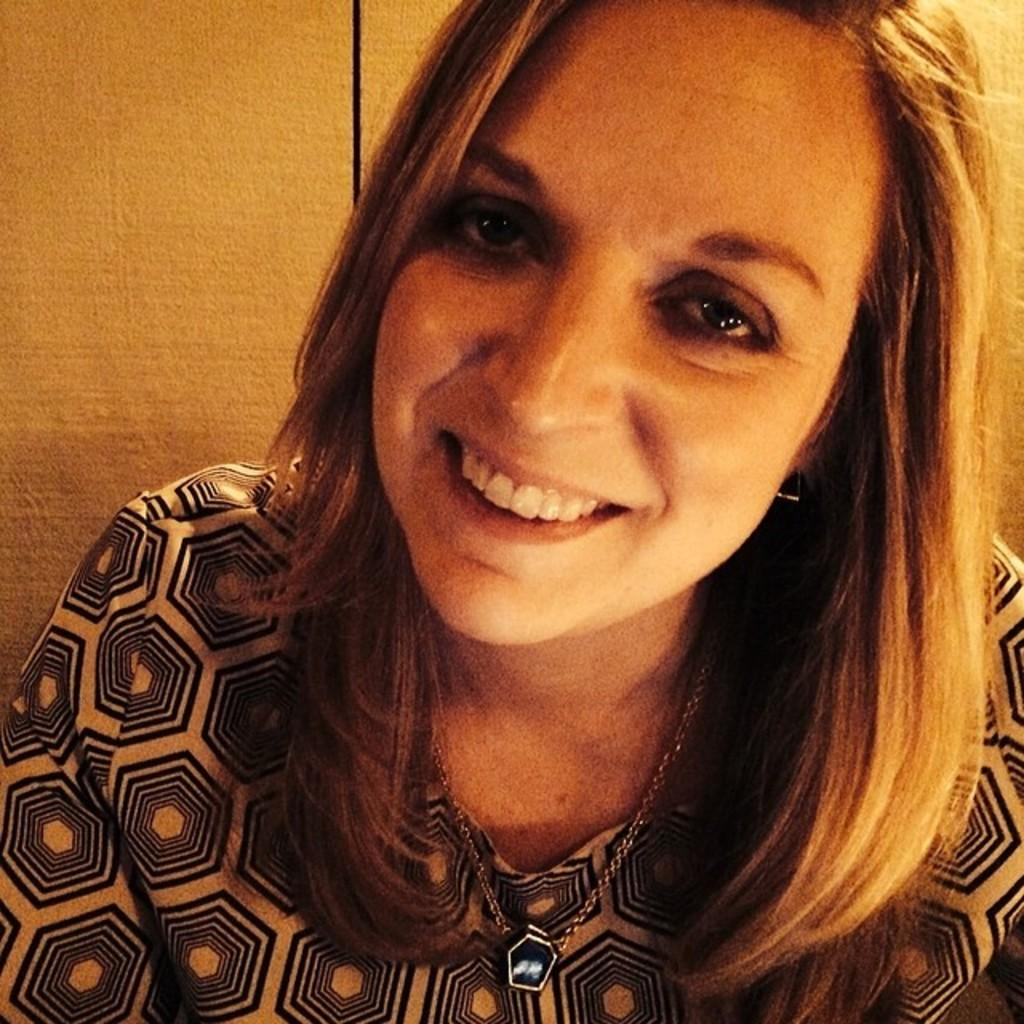Who is present in the image? There is a woman in the image. What is the woman wearing? The woman is wearing a chain. What is the woman's facial expression? The woman is smiling. What is the woman's posture in the image? The woman is sitting. What can be seen in the background of the image? There is a wall in the image. What type of shop can be seen on the sidewalk in the image? There is no shop or sidewalk present in the image; it features a woman sitting and smiling. Can you describe the van parked near the woman in the image? There is no van present in the image; it only features a woman sitting and smiling. 